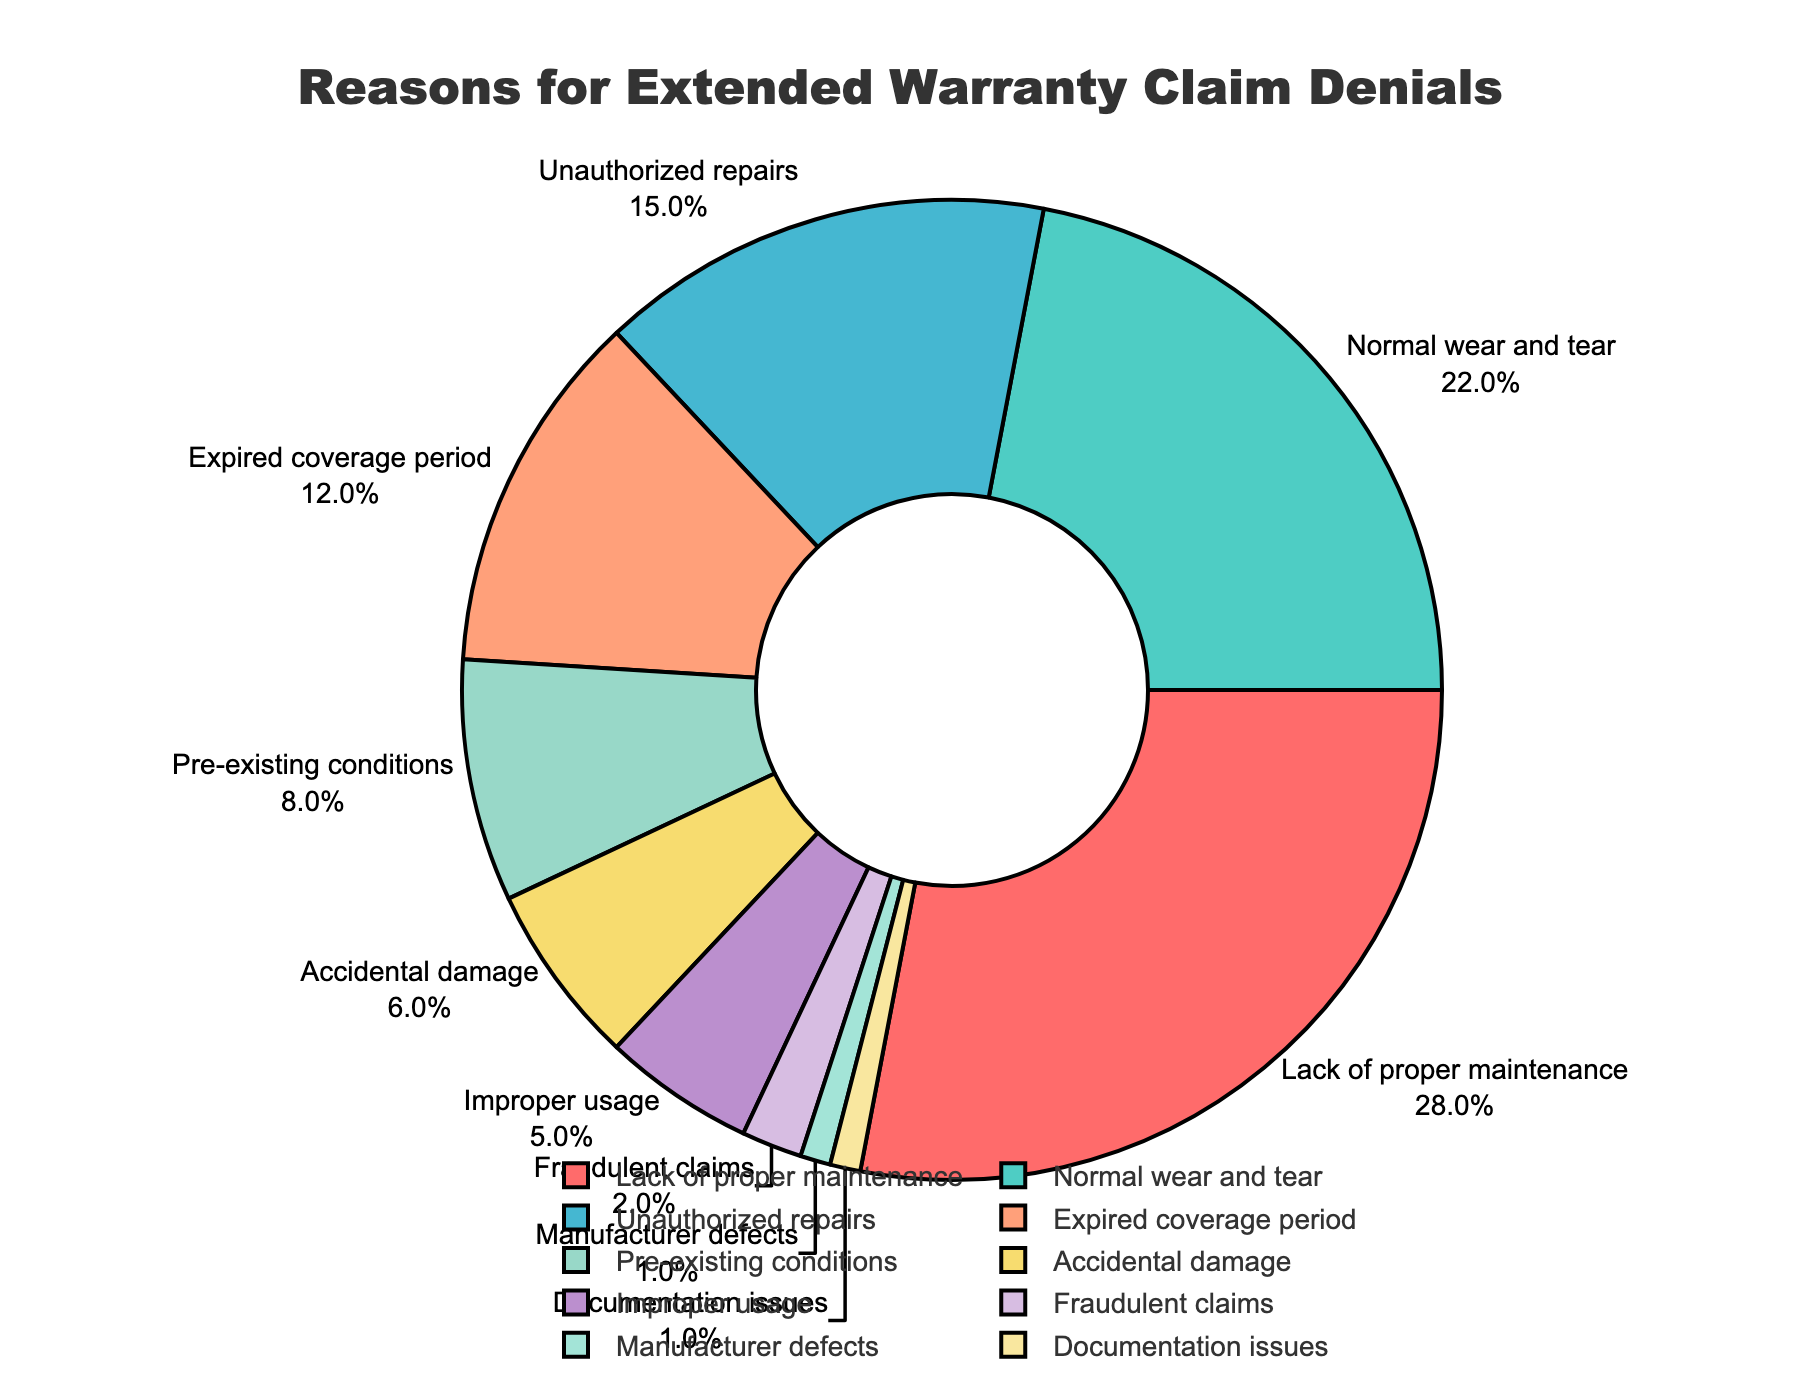What is the most common reason for extended warranty claim denials? According to the figure, the reason with the highest percentage is the most common reason. In this case, "Lack of proper maintenance" has the largest segment with 28%.
Answer: Lack of proper maintenance How much more frequent are claims denied due to "Lack of proper maintenance" compared to "Pre-existing conditions"? First, locate the percentages for both reasons: "Lack of proper maintenance" is 28%, and "Pre-existing conditions" is 8%. Subtract the smaller value from the larger value: 28% - 8% = 20%.
Answer: 20% Are claims denied due to "Unauthorized repairs" more or less frequent than those denied due to "Normal wear and tear"? Compare the two percentages: "Unauthorized repairs" is 15%, and "Normal wear and tear" is 22%. Since 15% is less than 22%, claims are denied less frequently due to "Unauthorized repairs" than "Normal wear and tear".
Answer: Less frequent What percentage of claims are denied for "Accidental damage" and "Improper usage" combined? Identify the percentages for each reason: "Accidental damage" is 6% and "Improper usage" is 5%. Add these percentages together: 6% + 5% = 11%.
Answer: 11% How does the frequency of claim denials for "Expired coverage period" compare to that for "Fraudulent claims"? First, find the percentages for both reasons: "Expired coverage period" is 12%, and "Fraudulent claims" is 2%. Since 12% is greater than 2%, claims are denied more frequently due to "Expired coverage period" than "Fraudulent claims".
Answer: More frequent What is the total percentage of claims denied for reasons "Accidental damage", "Improper usage", and "Documentation issues"? Identify the percentages for each reason: "Accidental damage" is 6%, "Improper usage" is 5%, and "Documentation issues" is 1%. Add these percentages together: 6% + 5% + 1% = 12%.
Answer: 12% Which reason for claim denials has the smallest percentage, and what is that percentage? Locate the reason with the smallest segment in the pie chart. "Manufacturer defects" and "Documentation issues" both have the smallest segments with 1%.
Answer: Manufacturer defects and Documentation issues, 1% If you combine the percentages for "Normal wear and tear" and "Unauthorized repairs", how much does this combined percentage represent compared to the sum of all other categories? First, add the percentages for "Normal wear and tear" (22%) and "Unauthorized repairs" (15%): 22% + 15% = 37%. Then sum all percentages: 100%. Subtract the combined percentage from the total: 100% - 37% = 63%. The combined percentage is 37%, while the sum of all other categories is 63%.
Answer: 37% compared to 63% Are there any less common reasons with a percentage of less than 5%? If so, what are they? Reasons with a percentage of less than 5% are "Improper usage" (5%), "Fraudulent claims" (2%), "Manufacturer defects" (1%), and "Documentation issues" (1%).
Answer: Yes, Fraudulent claims, Manufacturer defects, Documentation issues 